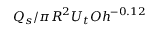<formula> <loc_0><loc_0><loc_500><loc_500>Q _ { s } / \pi R ^ { 2 } U _ { t } O h ^ { - 0 . 1 2 }</formula> 